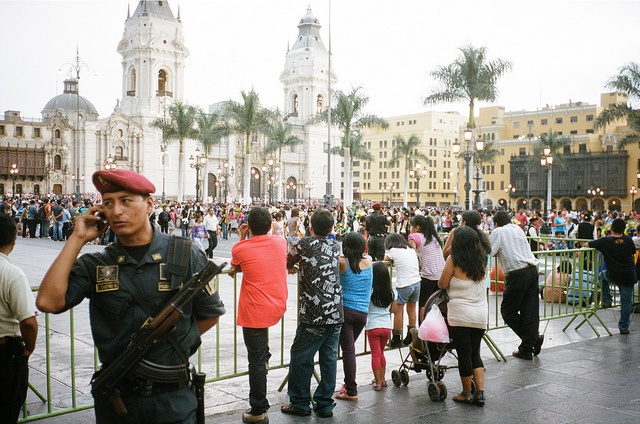Describe the objects in this image and their specific colors. I can see people in white, black, brown, and maroon tones, people in white, black, lightgray, darkgray, and gray tones, people in white, black, gray, darkgray, and lightgray tones, people in white, salmon, black, red, and lightgray tones, and people in white, black, darkgray, lightgray, and maroon tones in this image. 